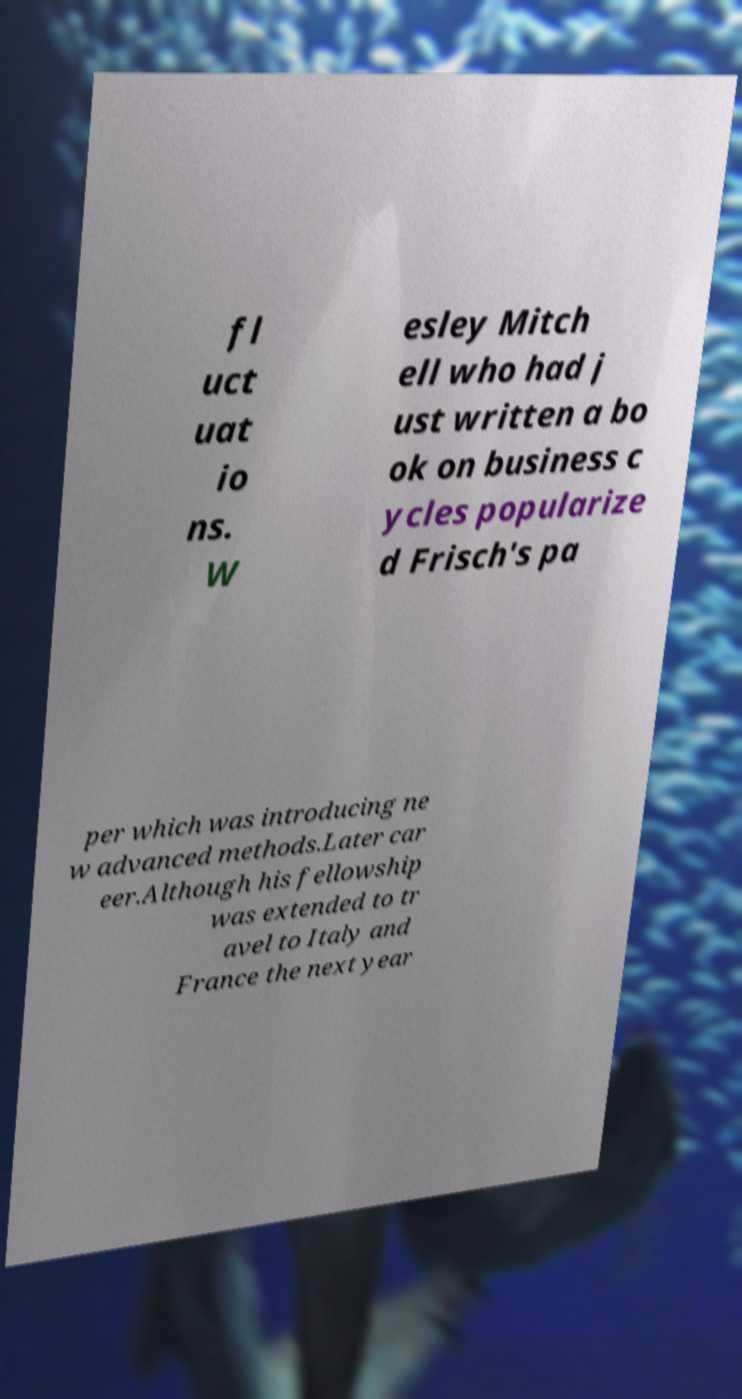Could you assist in decoding the text presented in this image and type it out clearly? fl uct uat io ns. W esley Mitch ell who had j ust written a bo ok on business c ycles popularize d Frisch's pa per which was introducing ne w advanced methods.Later car eer.Although his fellowship was extended to tr avel to Italy and France the next year 